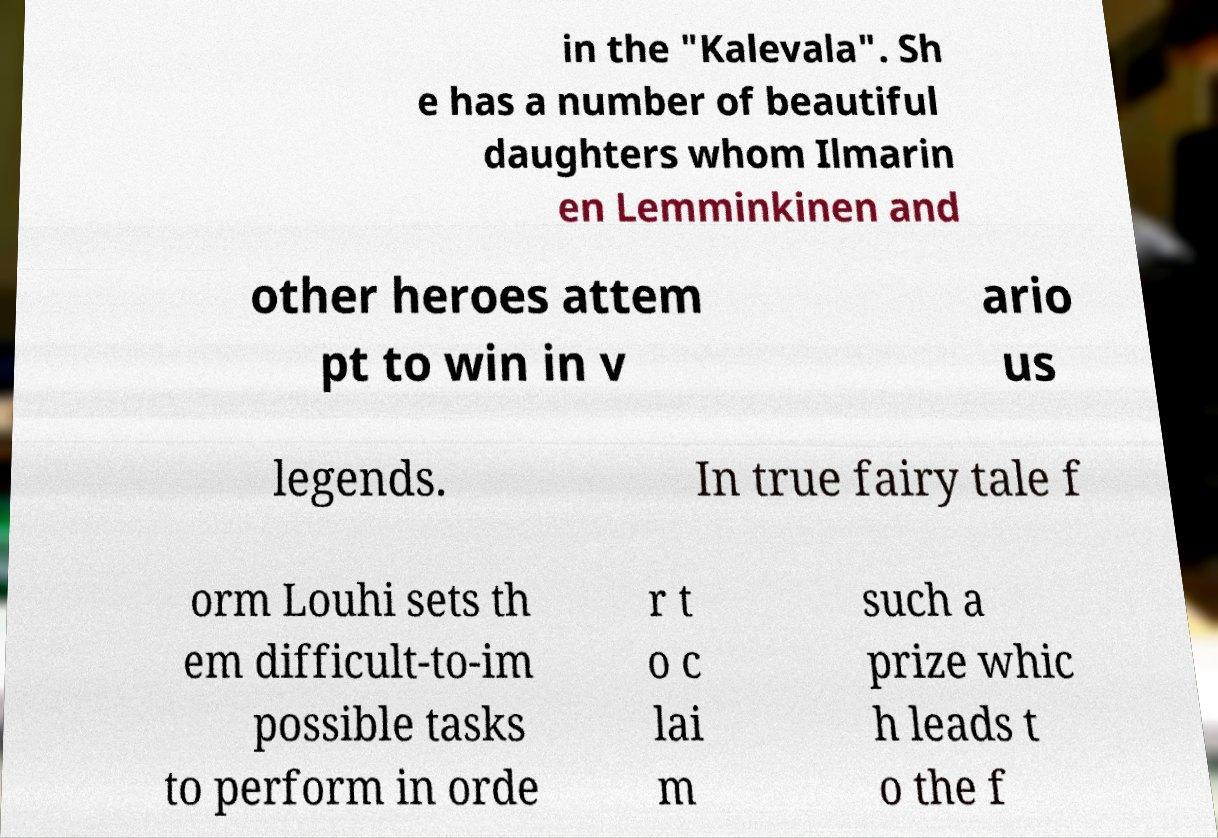Please read and relay the text visible in this image. What does it say? in the "Kalevala". Sh e has a number of beautiful daughters whom Ilmarin en Lemminkinen and other heroes attem pt to win in v ario us legends. In true fairy tale f orm Louhi sets th em difficult-to-im possible tasks to perform in orde r t o c lai m such a prize whic h leads t o the f 